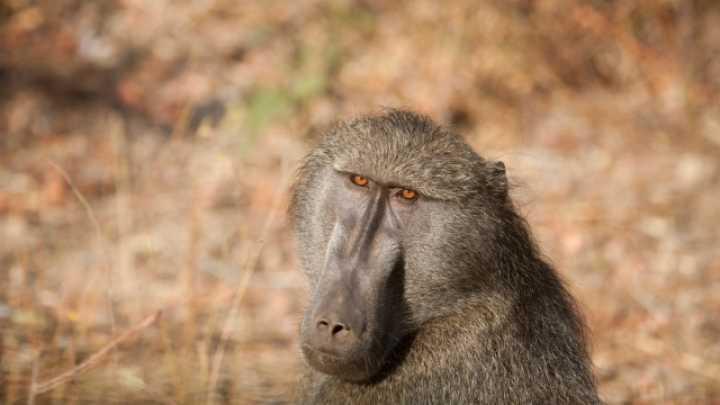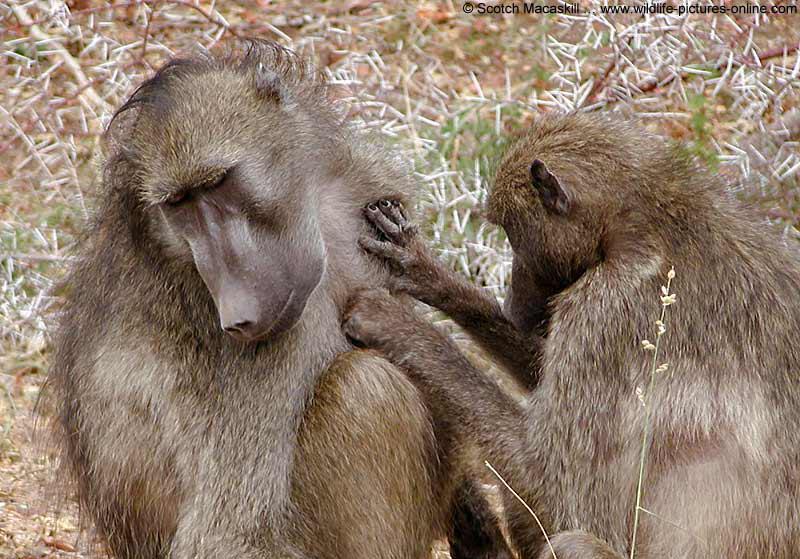The first image is the image on the left, the second image is the image on the right. Given the left and right images, does the statement "The combined images contain six baboons." hold true? Answer yes or no. No. The first image is the image on the left, the second image is the image on the right. Analyze the images presented: Is the assertion "The left image contains no more than two monkeys." valid? Answer yes or no. Yes. 